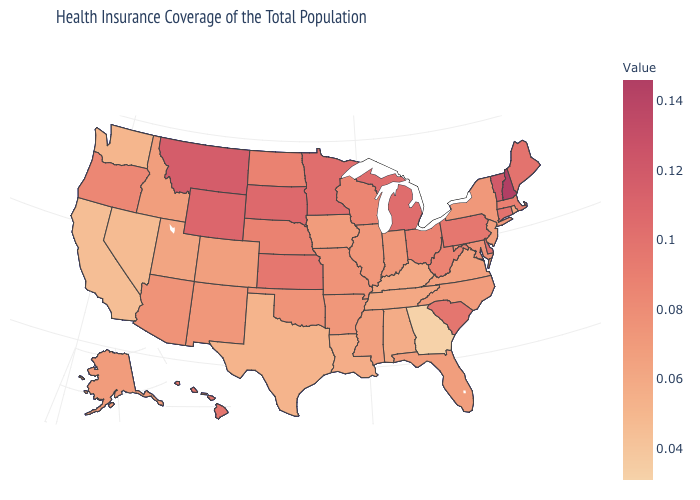Which states have the lowest value in the USA?
Write a very short answer. Georgia. Does New Hampshire have the highest value in the USA?
Keep it brief. Yes. Which states have the lowest value in the Northeast?
Keep it brief. Rhode Island. Which states hav the highest value in the MidWest?
Write a very short answer. South Dakota. Which states have the highest value in the USA?
Answer briefly. New Hampshire. 